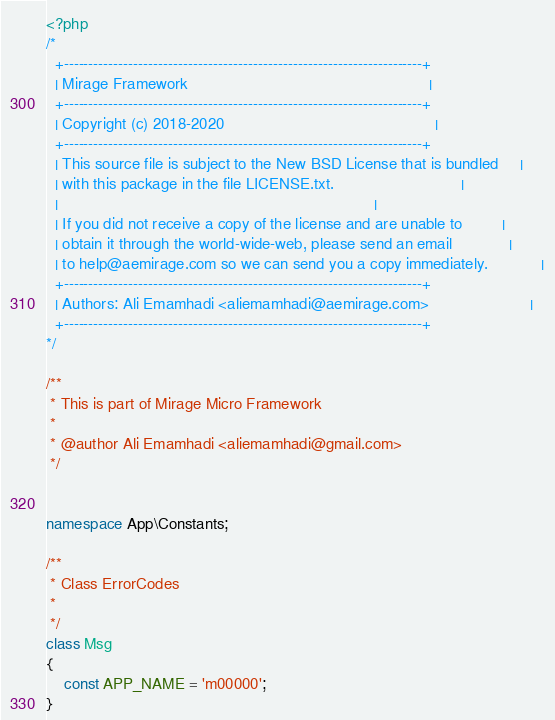Convert code to text. <code><loc_0><loc_0><loc_500><loc_500><_PHP_><?php
/*
  +------------------------------------------------------------------------+
  | Mirage Framework                                                       |
  +------------------------------------------------------------------------+
  | Copyright (c) 2018-2020                                                |
  +------------------------------------------------------------------------+
  | This source file is subject to the New BSD License that is bundled     |
  | with this package in the file LICENSE.txt.                             |
  |                                                                        |
  | If you did not receive a copy of the license and are unable to         |
  | obtain it through the world-wide-web, please send an email             |
  | to help@aemirage.com so we can send you a copy immediately.            |
  +------------------------------------------------------------------------+
  | Authors: Ali Emamhadi <aliemamhadi@aemirage.com>                       |
  +------------------------------------------------------------------------+
*/

/**
 * This is part of Mirage Micro Framework
 *
 * @author Ali Emamhadi <aliemamhadi@gmail.com>
 */


namespace App\Constants;

/**
 * Class ErrorCodes
 *
 */
class Msg
{
    const APP_NAME = 'm00000';
}
</code> 